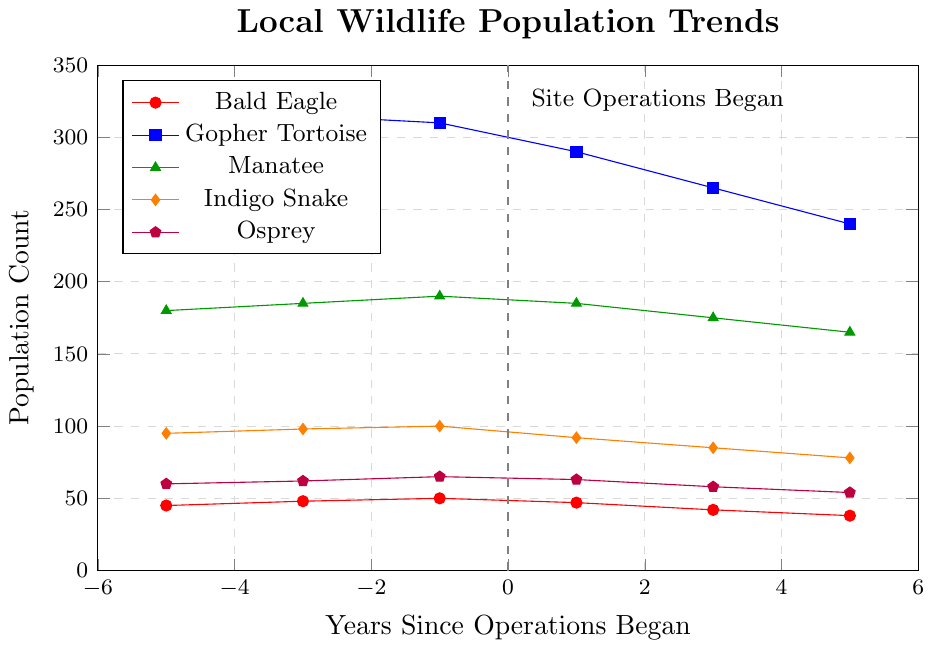what is the population count of the Osprey 5 years after site operations began? Find the data point for Osprey at 5 years after site operations began. The count is 54.
Answer: 54 Which species experienced the most significant decline in population count 5 years after the site operations began compared to their population 1 year before the site operations began? Calculate the population count difference for each species between -1 and 5 years. The decline for each species is: Bald Eagle (50 to 38, decline of 12), Gopher Tortoise (310 to 240, decline of 70), Manatee (190 to 165, decline of 25), Indigo Snake (100 to 78, decline of 22), Osprey (65 to 54, decline of 11). The Gopher Tortoise experienced the most significant decline of 70.
Answer: Gopher Tortoise How does the population trend of Bald Eagle compare to Indigo Snake over the observed period? Visually compare the declining trends of both species from -5 to 5 years. Both species show a decline after the operations began, but the Indigo Snake's population consistently decreases while the Bald Eagle shows a slight increase initially before declining.
Answer: Both decline, Indigo Snake consistently Which species’ population remained the most stable over time? By examining the trends, each species shows varying degrees of decline, but the Manatee has the least fluctuation and the smallest overall decline, making it the most stable.
Answer: Manatee What is the average population count of the Gopher Tortoise before the site operations began? Calculate the average of the population counts for Gopher Tortoise at -5, -3, and -1 years: (320 + 315 + 310) / 3 = 945 / 3 = 315.
Answer: 315 Which species had a population peak closest to the time when site operations began? Identify the peak population counts close to the year 0 for each species. The Bald Eagle has a peak at -1 year (50).
Answer: Bald Eagle What is the ratio of the population of the Manatee to the Gopher Tortoise 3 years after the site operations began? Find the population counts for both species at 3 years after operations began: Manatee (175), Gopher Tortoise (265). Calculate the ratio 175/265 ≈ 0.66.
Answer: 0.66 